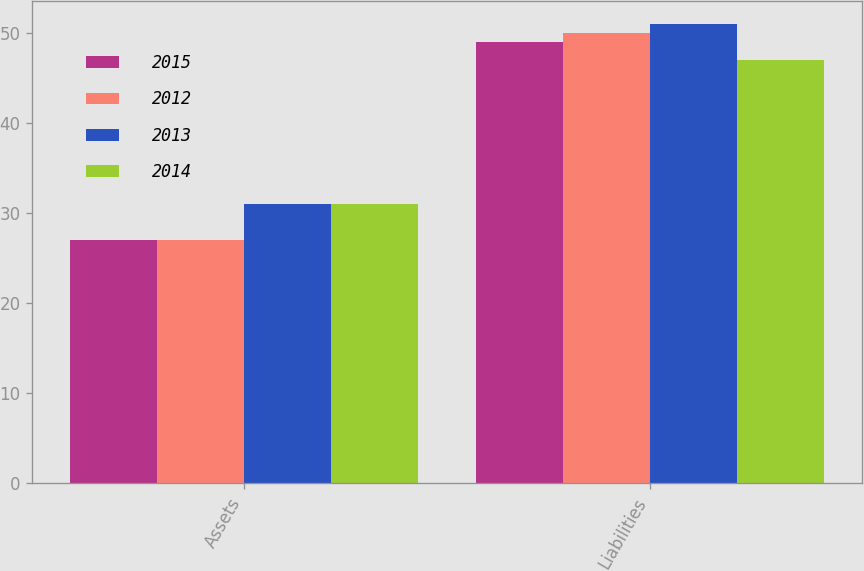<chart> <loc_0><loc_0><loc_500><loc_500><stacked_bar_chart><ecel><fcel>Assets<fcel>Liabilities<nl><fcel>2015<fcel>27<fcel>49<nl><fcel>2012<fcel>27<fcel>50<nl><fcel>2013<fcel>31<fcel>51<nl><fcel>2014<fcel>31<fcel>47<nl></chart> 